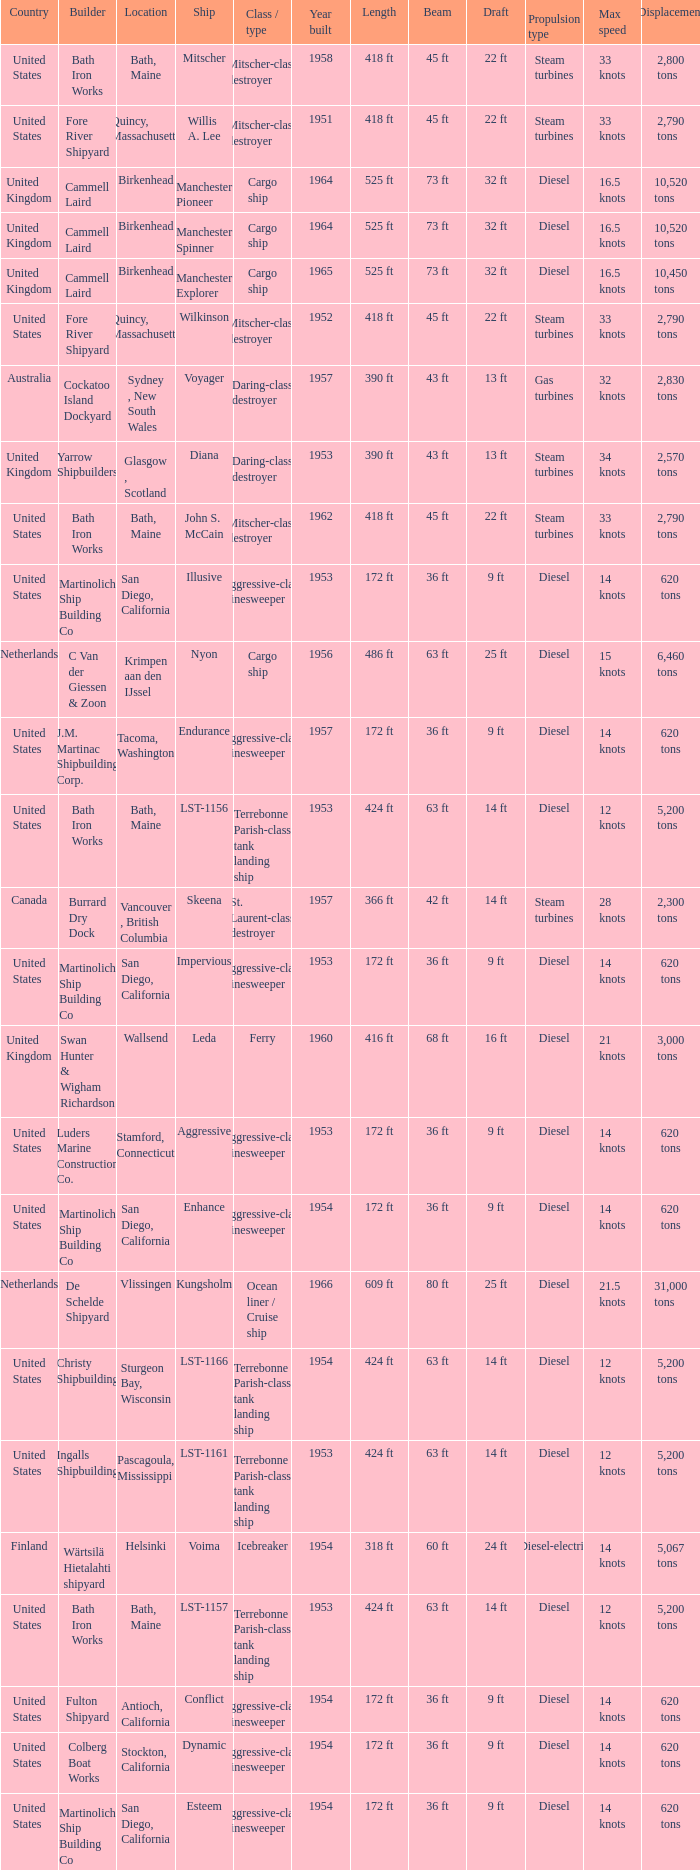What Country is the John S. McCain Ship from? United States. 